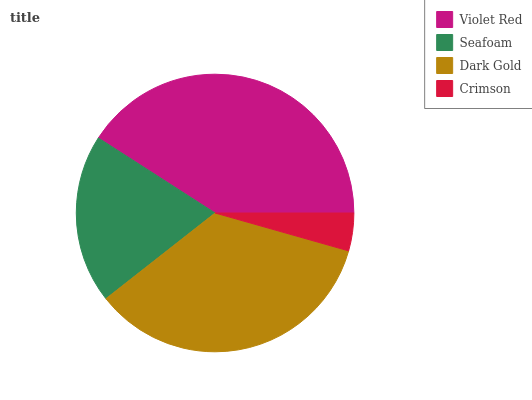Is Crimson the minimum?
Answer yes or no. Yes. Is Violet Red the maximum?
Answer yes or no. Yes. Is Seafoam the minimum?
Answer yes or no. No. Is Seafoam the maximum?
Answer yes or no. No. Is Violet Red greater than Seafoam?
Answer yes or no. Yes. Is Seafoam less than Violet Red?
Answer yes or no. Yes. Is Seafoam greater than Violet Red?
Answer yes or no. No. Is Violet Red less than Seafoam?
Answer yes or no. No. Is Dark Gold the high median?
Answer yes or no. Yes. Is Seafoam the low median?
Answer yes or no. Yes. Is Seafoam the high median?
Answer yes or no. No. Is Violet Red the low median?
Answer yes or no. No. 